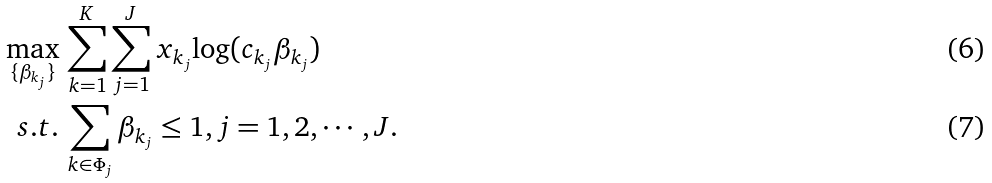<formula> <loc_0><loc_0><loc_500><loc_500>\max _ { \{ \beta _ { k _ { j } } \} } & \, \sum _ { k = 1 } ^ { K } \sum _ { j = 1 } ^ { J } x _ { k _ { j } } { \log ( c _ { k _ { j } } \beta _ { k _ { j } } ) } \\ s . t . & \, \sum _ { k \in \Phi _ { j } } \beta _ { k _ { j } } \leq 1 , j = 1 , 2 , \cdots , J .</formula> 